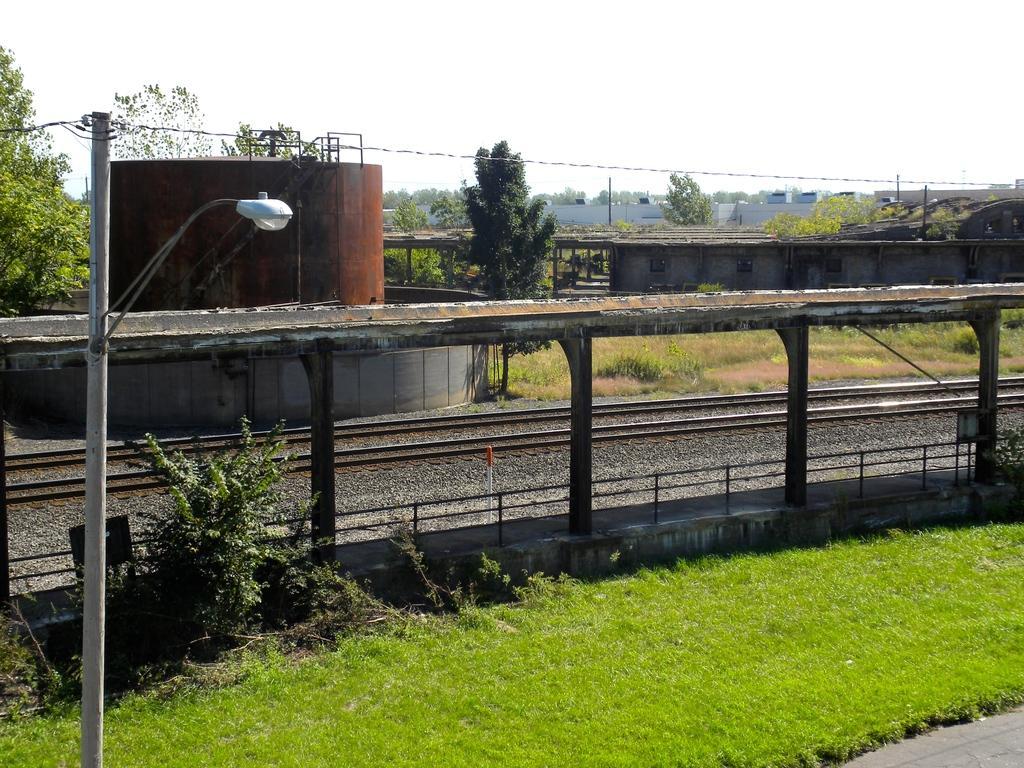Could you give a brief overview of what you see in this image? In this image we can see the railway tracks. Image also consists of electrical poles with wires, trees, buildings and we can also see the roof for shelter. At the top there is sky and at the bottom there is grass. 